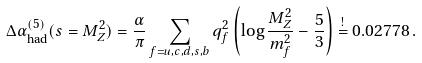Convert formula to latex. <formula><loc_0><loc_0><loc_500><loc_500>\Delta \alpha _ { \text {had} } ^ { ( 5 ) } ( s = M _ { Z } ^ { 2 } ) = \frac { \alpha } { \pi } \sum _ { f = u , c , d , s , b } q _ { f } ^ { 2 } \left ( \log \frac { M _ { Z } ^ { 2 } } { m _ { f } ^ { 2 } } - \frac { 5 } { 3 } \right ) \overset { ! } { = } 0 . 0 2 7 7 8 \, .</formula> 